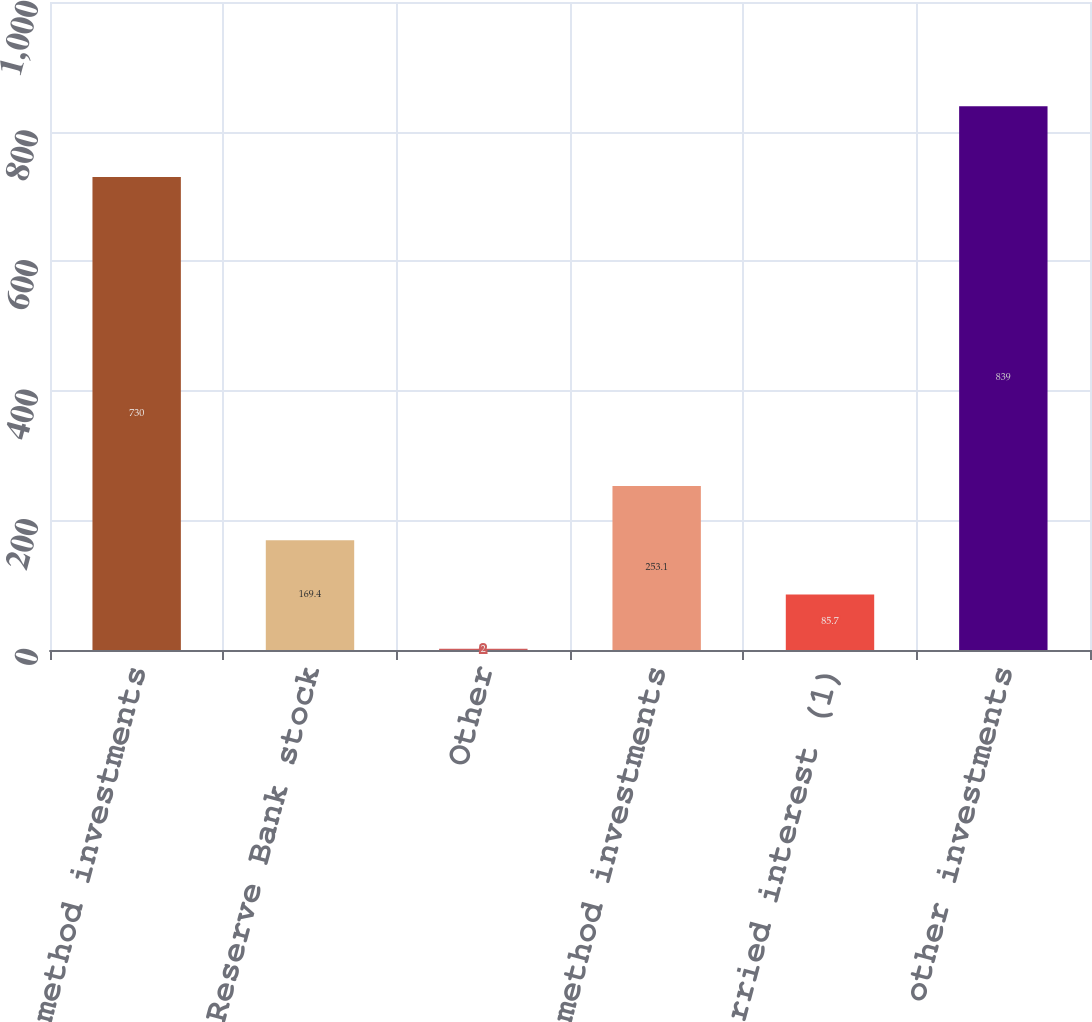Convert chart. <chart><loc_0><loc_0><loc_500><loc_500><bar_chart><fcel>Equity method investments<fcel>Federal Reserve Bank stock<fcel>Other<fcel>Total cost method investments<fcel>Carried interest (1)<fcel>Total other investments<nl><fcel>730<fcel>169.4<fcel>2<fcel>253.1<fcel>85.7<fcel>839<nl></chart> 